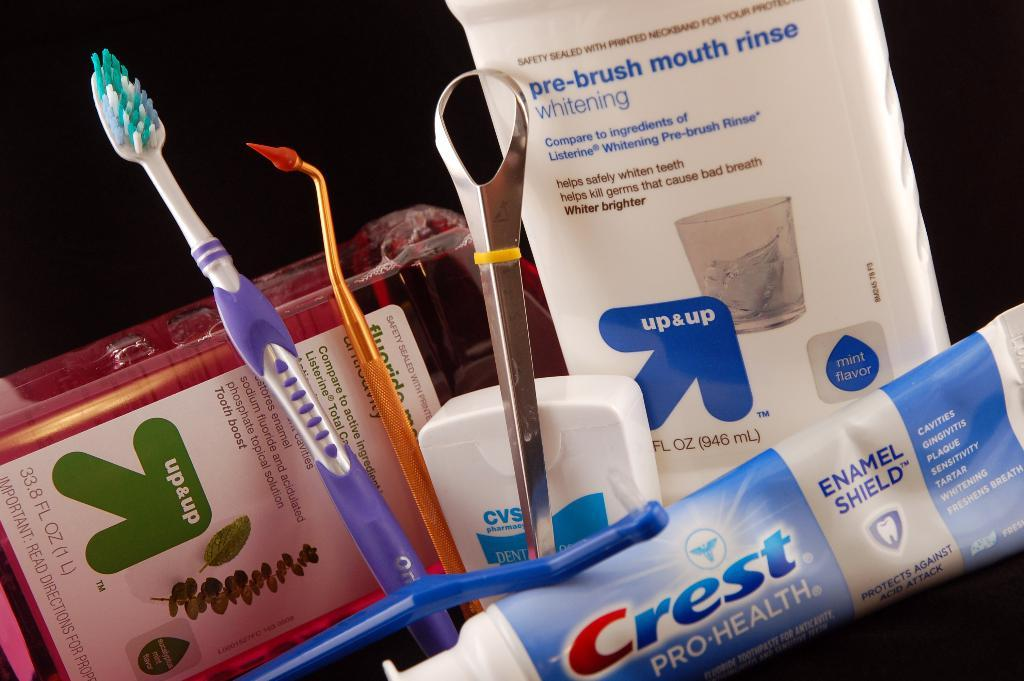<image>
Describe the image concisely. Different oral hygeine products including a tube of Crest. 